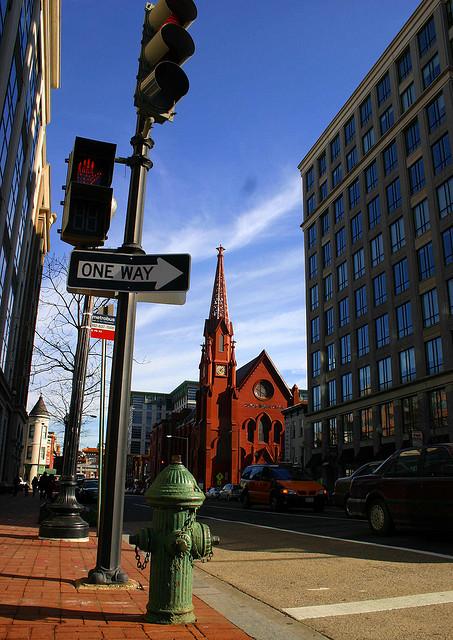What does the sign say?
Concise answer only. One way. What color is the fire hydrant?
Be succinct. Green. Is it a sunny day?
Short answer required. Yes. How many orange traffic cones are in the photo?
Answer briefly. 0. Can you turn left?
Give a very brief answer. No. How many stories is the building on the right?
Be succinct. 10. Will I take the chance of being hit if I walk?
Keep it brief. Yes. What color is the church building in the background?
Concise answer only. Red. How many colors is the fire hydrant?
Be succinct. 1. 